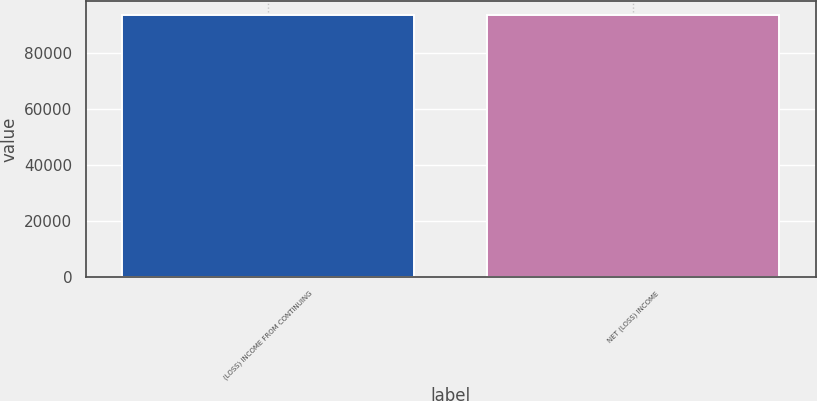<chart> <loc_0><loc_0><loc_500><loc_500><bar_chart><fcel>(LOSS) INCOME FROM CONTINUING<fcel>NET (LOSS) INCOME<nl><fcel>93645.1<fcel>93645.2<nl></chart> 